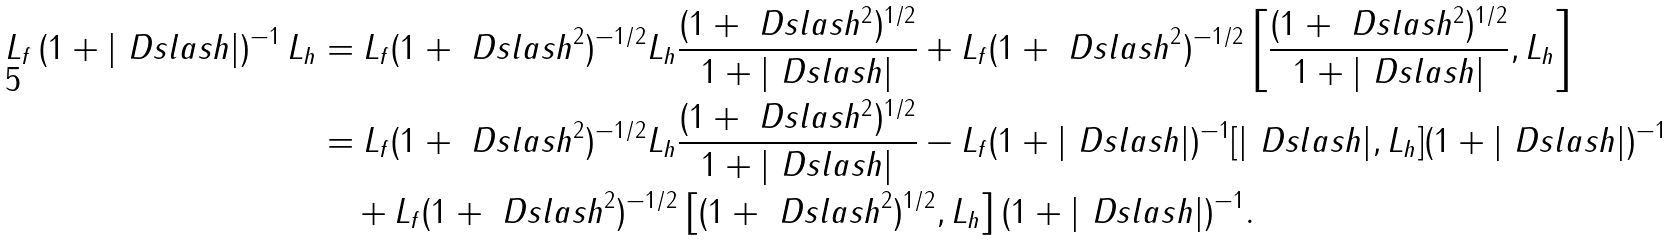Convert formula to latex. <formula><loc_0><loc_0><loc_500><loc_500>L _ { f } \, ( 1 + | \ D s l a s h | ) ^ { - 1 } \, L _ { h } & = L _ { f } ( 1 + \ D s l a s h ^ { 2 } ) ^ { - 1 / 2 } L _ { h } \frac { ( 1 + \ D s l a s h ^ { 2 } ) ^ { 1 / 2 } } { 1 + | \ D s l a s h | } + L _ { f } ( 1 + \ D s l a s h ^ { 2 } ) ^ { - 1 / 2 } \left [ \frac { ( 1 + \ D s l a s h ^ { 2 } ) ^ { 1 / 2 } } { 1 + | \ D s l a s h | } , L _ { h } \right ] \\ & = L _ { f } ( 1 + \ D s l a s h ^ { 2 } ) ^ { - 1 / 2 } L _ { h } \frac { ( 1 + \ D s l a s h ^ { 2 } ) ^ { 1 / 2 } } { 1 + | \ D s l a s h | } - L _ { f } ( 1 + | \ D s l a s h | ) ^ { - 1 } [ | \ D s l a s h | , L _ { h } ] ( 1 + | \ D s l a s h | ) ^ { - 1 } \\ & \quad + L _ { f } ( 1 + \ D s l a s h ^ { 2 } ) ^ { - 1 / 2 } \left [ ( 1 + \ D s l a s h ^ { 2 } ) ^ { 1 / 2 } , L _ { h } \right ] ( 1 + | \ D s l a s h | ) ^ { - 1 } .</formula> 